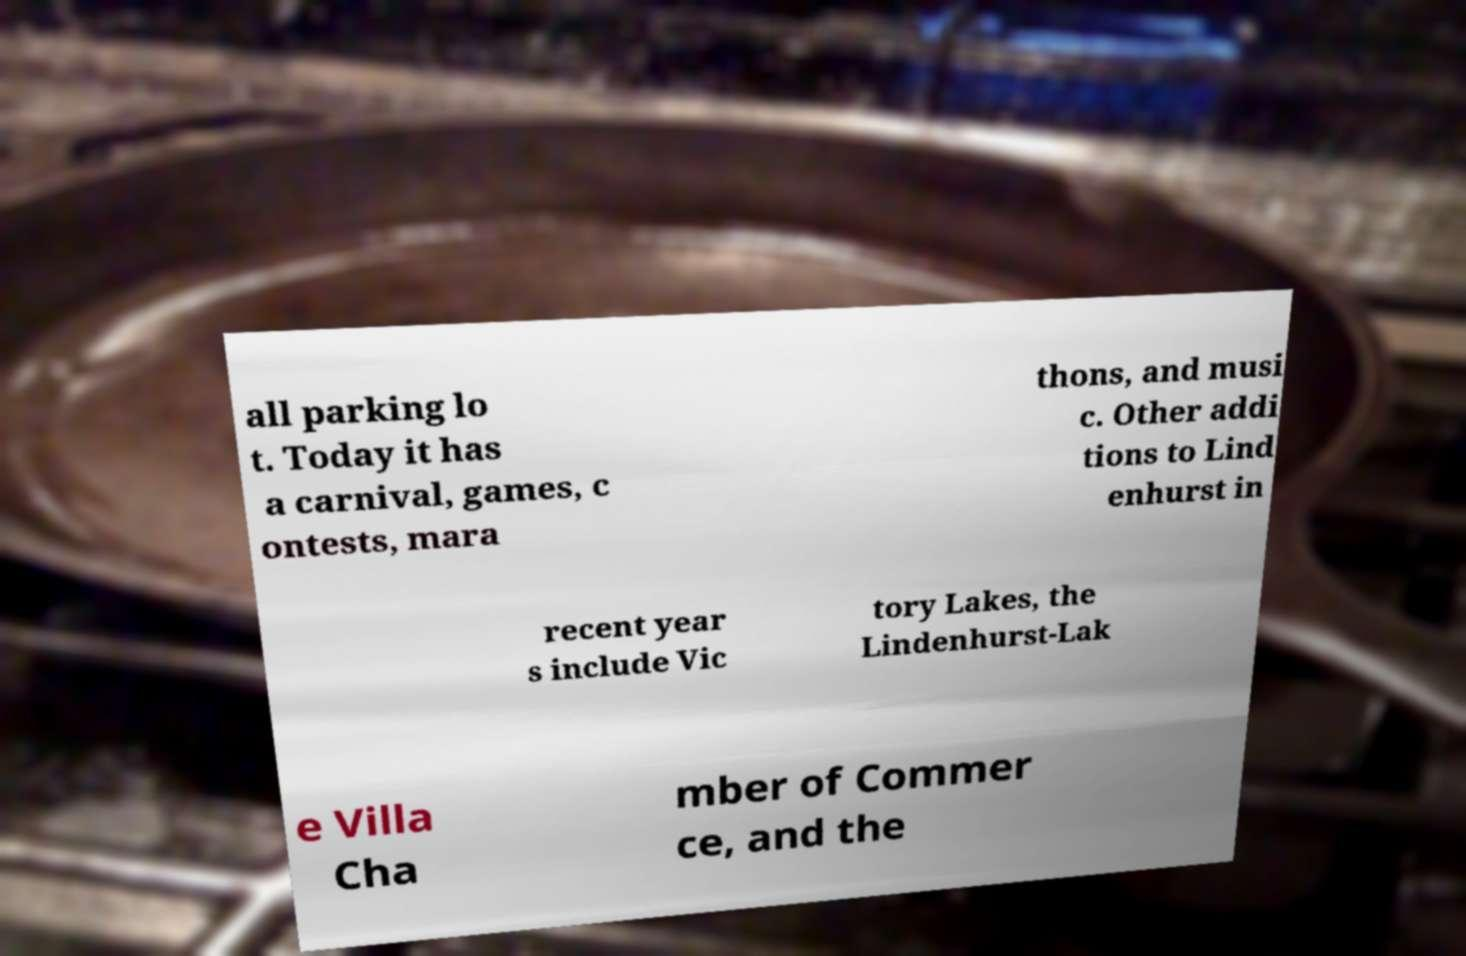Please identify and transcribe the text found in this image. all parking lo t. Today it has a carnival, games, c ontests, mara thons, and musi c. Other addi tions to Lind enhurst in recent year s include Vic tory Lakes, the Lindenhurst-Lak e Villa Cha mber of Commer ce, and the 